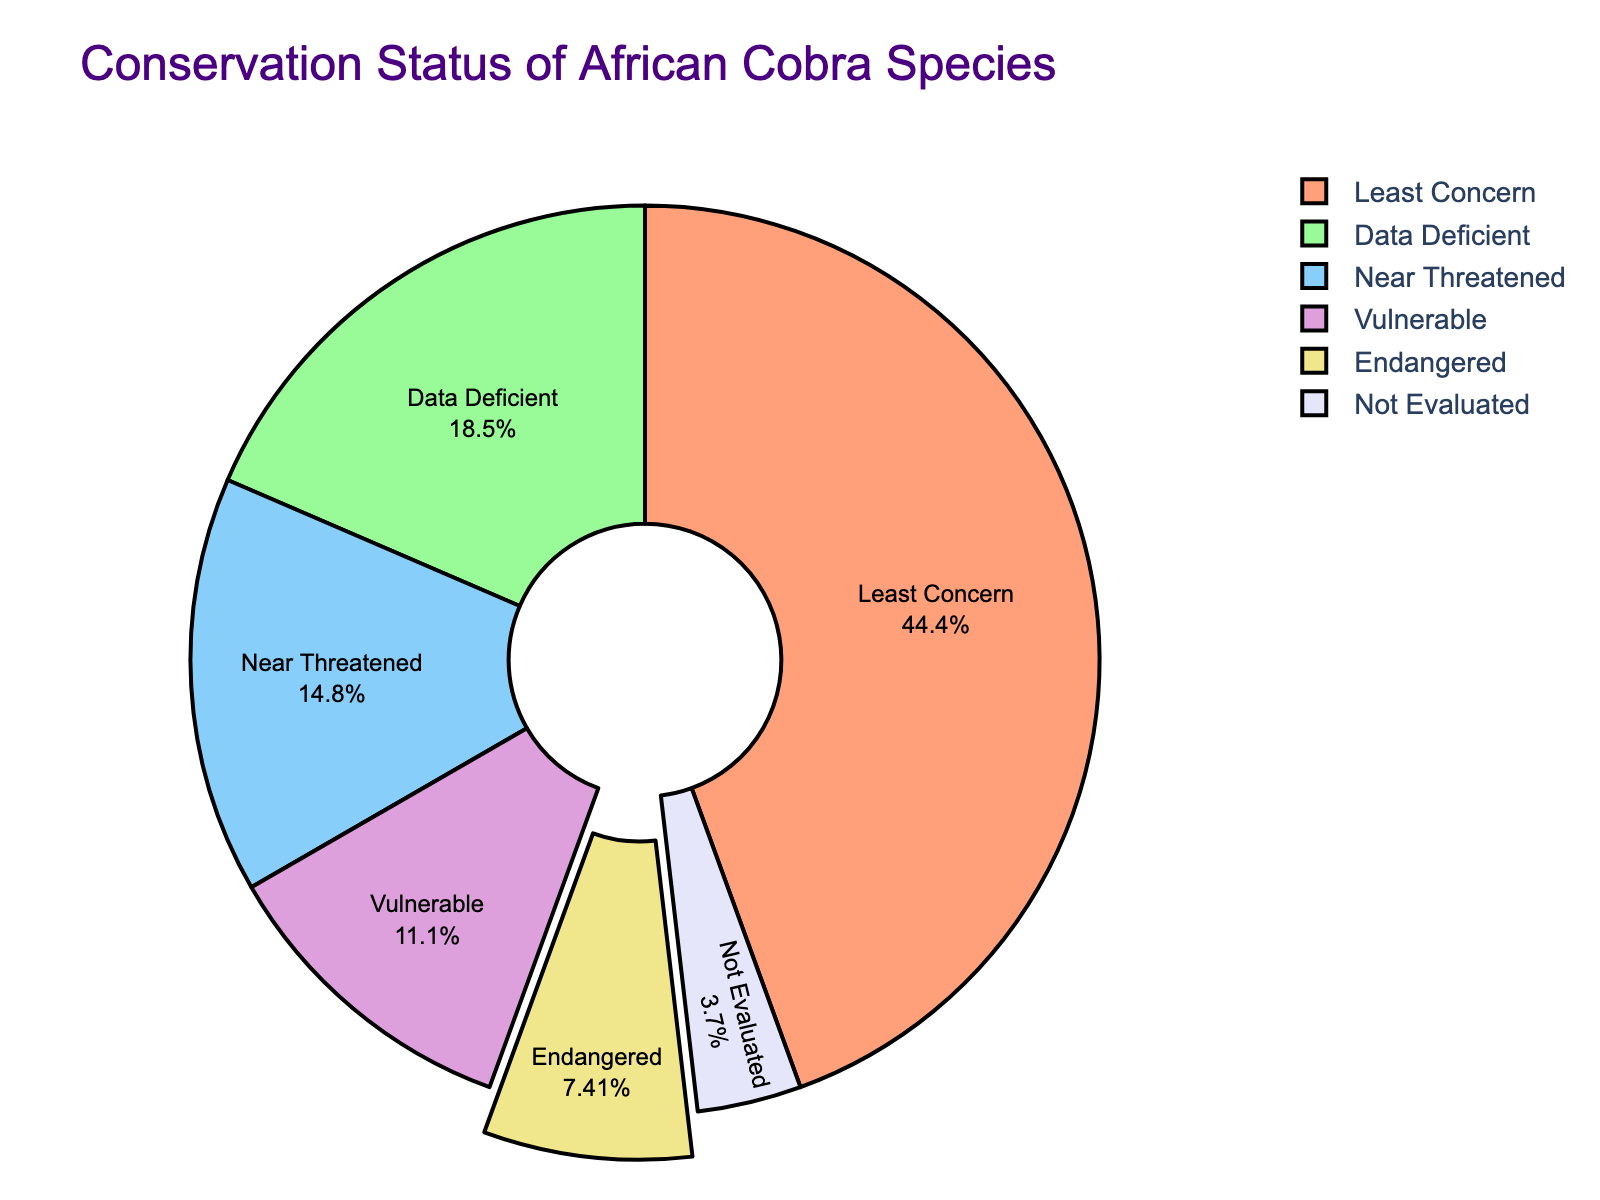What is the conservation status with the highest number of African cobra species? From the pie chart, identify which conservation status segment occupies the largest area. The segment labeled 'Least Concern' is the largest.
Answer: Least Concern Which conservation status has the smallest share of African cobra species? Observe the pie chart to find the smallest segment. The segment labeled 'Not Evaluated' is the smallest.
Answer: Not Evaluated What percentage of African cobra species are listed as 'Endangered'? The 'Endangered' segment is highlighted with a slight pull-out effect. The percentage label inside this segment shows 8.7%.
Answer: 8.7% How many African cobra species are either 'Vulnerable' or 'Endangered'? Sum the number of species in the 'Vulnerable' and 'Endangered' categories. There are 3 in 'Vulnerable' and 2 in 'Endangered', totaling 3 + 2 = 5.
Answer: 5 Are there more species in the 'Data Deficient' or 'Near Threatened' category? Compare the sizes or numbers of species in the 'Data Deficient' and 'Near Threatened' segments. 'Data Deficient' has 5 species, while 'Near Threatened' has 4 species.
Answer: Data Deficient What is the combined percentage of 'Least Concern' and 'Near Threatened' species? Add the percentages of the 'Least Concern' and 'Near Threatened' segments. 'Least Concern' is 52.2% and 'Near Threatened' is 17.4%, totaling 52.2% + 17.4% = 69.6%.
Answer: 69.6% Which color represents the 'Data Deficient' status? Identify the color of the segment labeled 'Data Deficient' in the pie chart. It is represented by the color that resembles khaki.
Answer: Khaki How many conservation statuses have fewer than 5 African cobra species each? Count the segments with labels indicating fewer than 5 species. 'Near Threatened', 'Vulnerable', 'Endangered', and 'Not Evaluated' all meet this criterion, so there are 4 statuses.
Answer: 4 What is the total number of African cobra species represented in the pie chart? Sum the number of species from all categories listed in the chart. Adding (12 + 4 + 3 + 2 + 5 + 1) gives a total of 27.
Answer: 27 